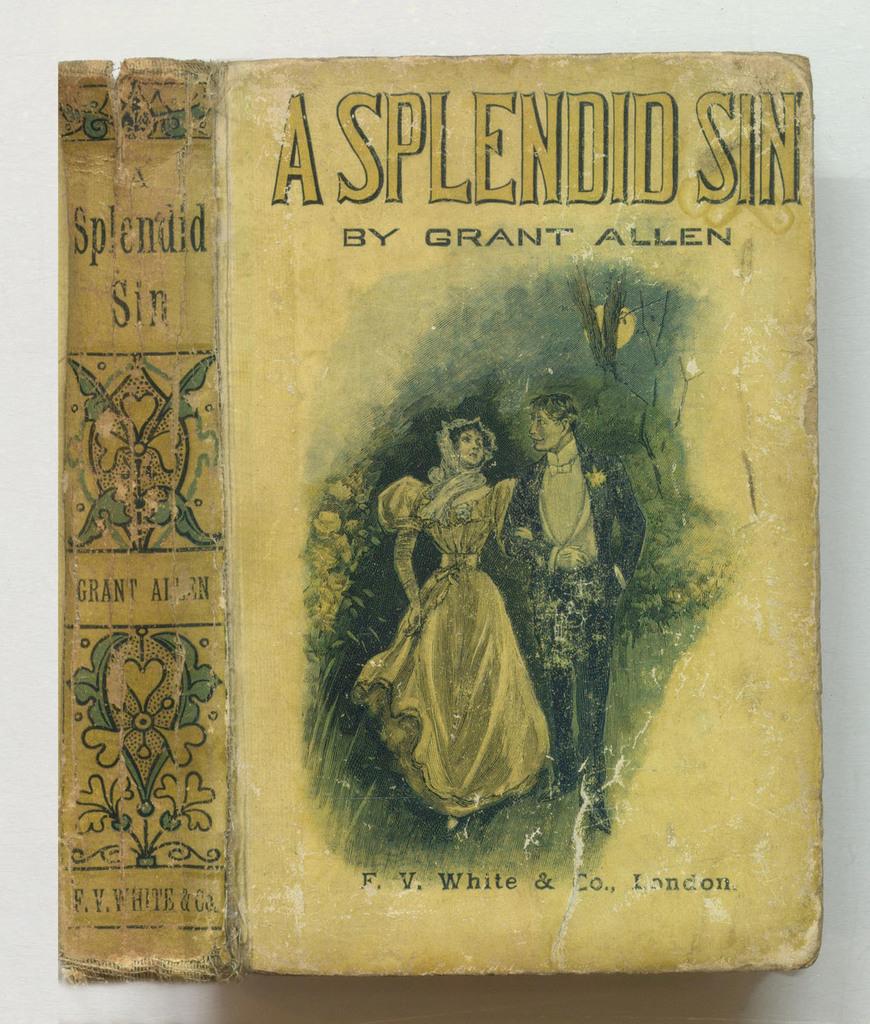What is the title of this book?
Offer a very short reply. A splendid sin. 